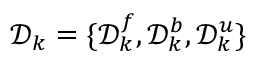<formula> <loc_0><loc_0><loc_500><loc_500>\mathcal { D } _ { k } = \{ \mathcal { D } _ { k } ^ { f } , \mathcal { D } _ { k } ^ { b } , \mathcal { D } _ { k } ^ { u } \}</formula> 